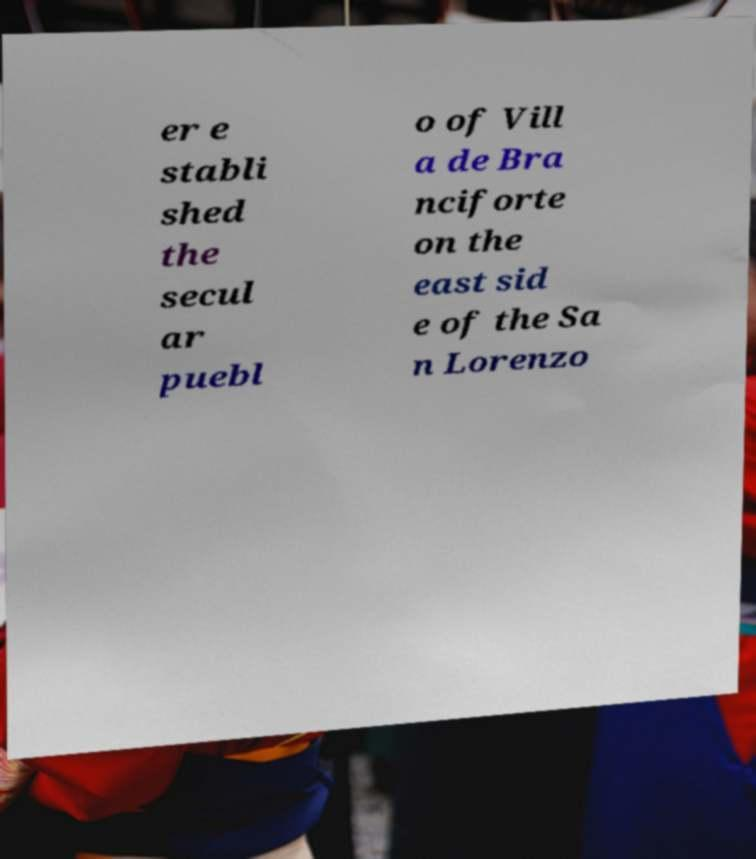Could you assist in decoding the text presented in this image and type it out clearly? er e stabli shed the secul ar puebl o of Vill a de Bra nciforte on the east sid e of the Sa n Lorenzo 